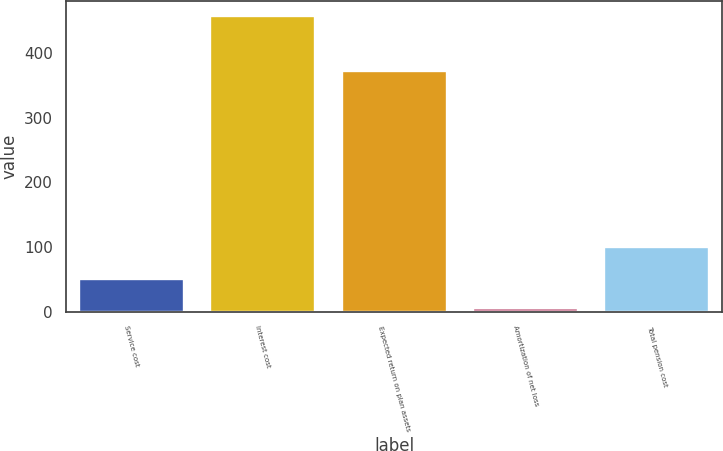Convert chart to OTSL. <chart><loc_0><loc_0><loc_500><loc_500><bar_chart><fcel>Service cost<fcel>Interest cost<fcel>Expected return on plan assets<fcel>Amortization of net loss<fcel>Total pension cost<nl><fcel>51.2<fcel>458<fcel>373<fcel>6<fcel>101<nl></chart> 